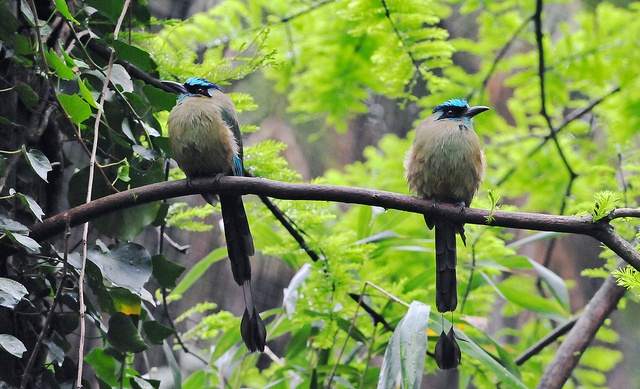Describe the objects in this image and their specific colors. I can see bird in black, gray, darkgray, and olive tones and bird in black, gray, and darkgray tones in this image. 